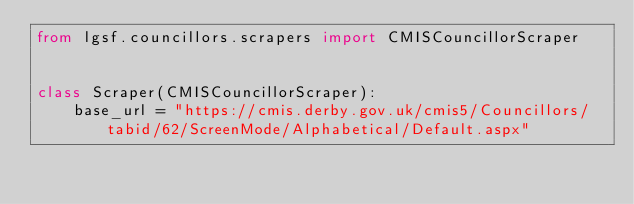<code> <loc_0><loc_0><loc_500><loc_500><_Python_>from lgsf.councillors.scrapers import CMISCouncillorScraper


class Scraper(CMISCouncillorScraper):
    base_url = "https://cmis.derby.gov.uk/cmis5/Councillors/tabid/62/ScreenMode/Alphabetical/Default.aspx"
</code> 